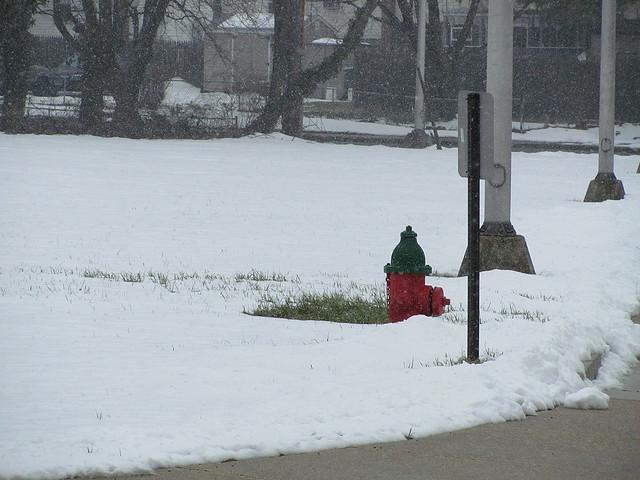How many bears are there?
Give a very brief answer. 0. 